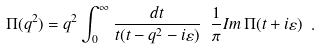<formula> <loc_0><loc_0><loc_500><loc_500>\Pi ( q ^ { 2 } ) = q ^ { 2 } \int _ { 0 } ^ { \infty } \frac { d t } { t ( t - q ^ { 2 } - i \varepsilon ) } \ \frac { 1 } { \pi } I m \, \Pi ( t + i \varepsilon ) \ .</formula> 